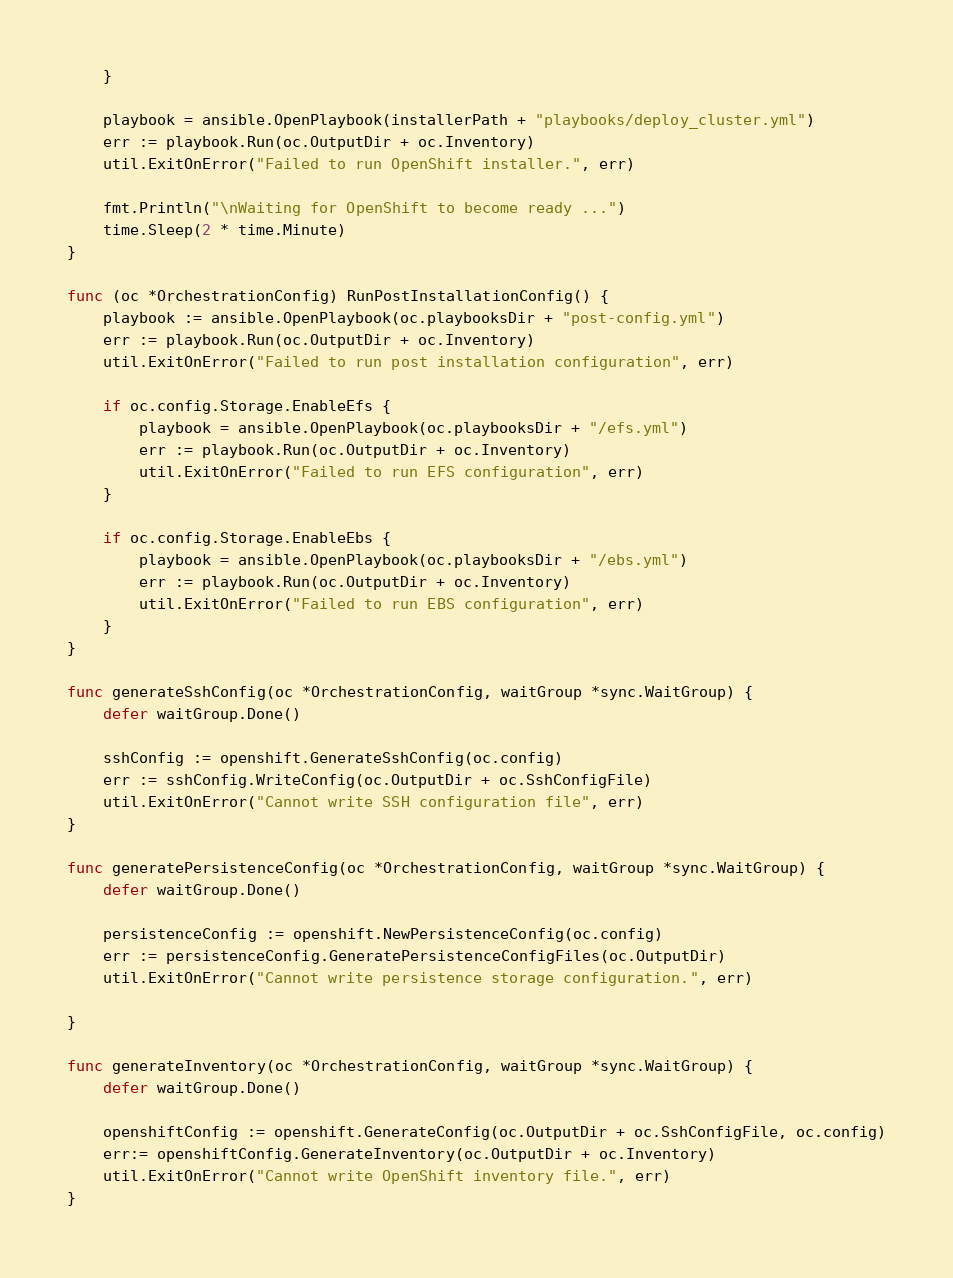Convert code to text. <code><loc_0><loc_0><loc_500><loc_500><_Go_>	}

	playbook = ansible.OpenPlaybook(installerPath + "playbooks/deploy_cluster.yml")
	err := playbook.Run(oc.OutputDir + oc.Inventory)
	util.ExitOnError("Failed to run OpenShift installer.", err)

	fmt.Println("\nWaiting for OpenShift to become ready ...")
	time.Sleep(2 * time.Minute)
}

func (oc *OrchestrationConfig) RunPostInstallationConfig() {
	playbook := ansible.OpenPlaybook(oc.playbooksDir + "post-config.yml")
	err := playbook.Run(oc.OutputDir + oc.Inventory)
	util.ExitOnError("Failed to run post installation configuration", err)

	if oc.config.Storage.EnableEfs {
		playbook = ansible.OpenPlaybook(oc.playbooksDir + "/efs.yml")
		err := playbook.Run(oc.OutputDir + oc.Inventory)
		util.ExitOnError("Failed to run EFS configuration", err)
	}

	if oc.config.Storage.EnableEbs {
		playbook = ansible.OpenPlaybook(oc.playbooksDir + "/ebs.yml")
		err := playbook.Run(oc.OutputDir + oc.Inventory)
		util.ExitOnError("Failed to run EBS configuration", err)
	}
}

func generateSshConfig(oc *OrchestrationConfig, waitGroup *sync.WaitGroup) {
	defer waitGroup.Done()

	sshConfig := openshift.GenerateSshConfig(oc.config)
	err := sshConfig.WriteConfig(oc.OutputDir + oc.SshConfigFile)
	util.ExitOnError("Cannot write SSH configuration file", err)
}

func generatePersistenceConfig(oc *OrchestrationConfig, waitGroup *sync.WaitGroup) {
	defer waitGroup.Done()

	persistenceConfig := openshift.NewPersistenceConfig(oc.config)
	err := persistenceConfig.GeneratePersistenceConfigFiles(oc.OutputDir)
	util.ExitOnError("Cannot write persistence storage configuration.", err)

}

func generateInventory(oc *OrchestrationConfig, waitGroup *sync.WaitGroup) {
	defer waitGroup.Done()

	openshiftConfig := openshift.GenerateConfig(oc.OutputDir + oc.SshConfigFile, oc.config)
	err:= openshiftConfig.GenerateInventory(oc.OutputDir + oc.Inventory)
	util.ExitOnError("Cannot write OpenShift inventory file.", err)
}</code> 